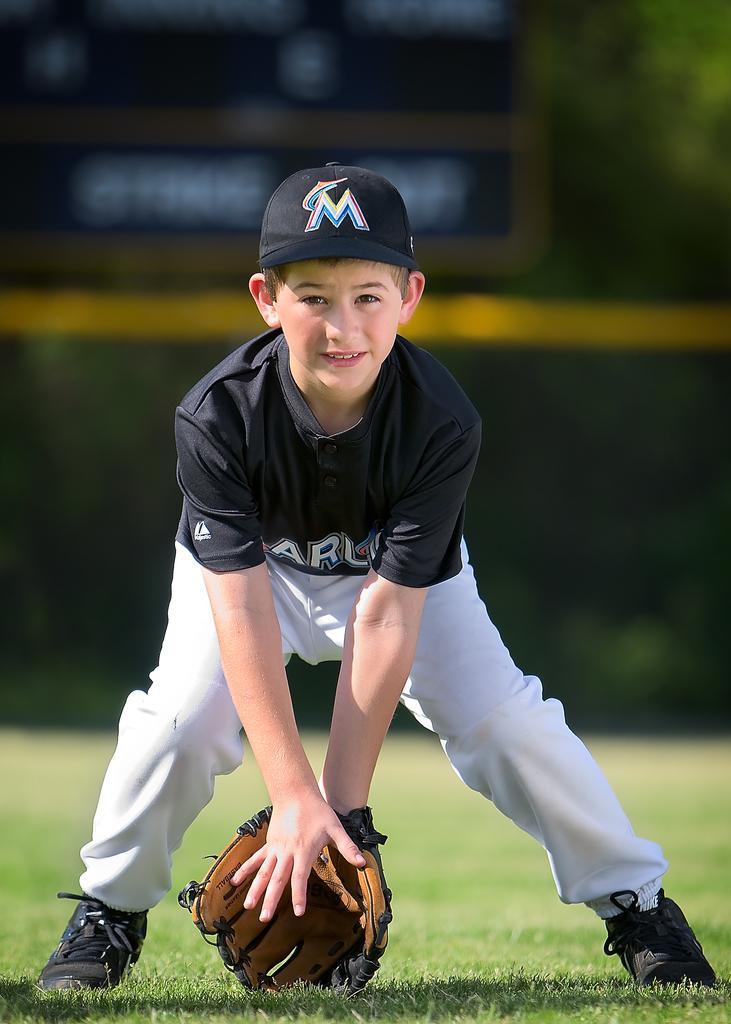Please provide a concise description of this image. In this image we can see a person and an object. In the background of the image there is a blur background. At the bottom of the image there is the grass. 